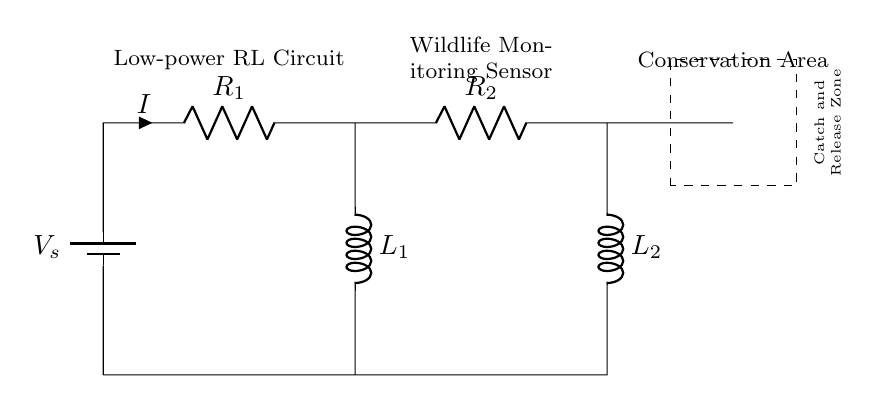What is the function of the battery in this circuit? The battery provides the voltage source needed to power the entire circuit, driving the current through the resistors and inductors.
Answer: Voltage source What are the names of the two resistors in the circuit? The resistors are labeled as R1 and R2, which indicates their positions and roles within the circuit.
Answer: R1 and R2 Which components are responsible for energy storage in the circuit? The inductors, L1 and L2, store energy in the magnetic field when current flows through them, distinguishing them from resistors, which dissipate energy.
Answer: L1 and L2 How many inductors are present in this circuit? There are two inductors, L1 and L2, connected in the circuit design, as indicated by the labels and their placement.
Answer: Two What type of sensor is being used in the circuit? The circuit includes a wildlife monitoring sensor, which is designed to function in conservation areas, helping keep track of animal movements and behaviors.
Answer: Wildlife monitoring sensor What does the dashed rectangle represent in the circuit? The dashed rectangle indicates a designated "Catch and Release Zone," suggesting an area where animals might be monitored without harm, aligning with conservation efforts.
Answer: Catch and Release Zone What is the significance of low power in this circuit? Low power consumption is crucial for wildlife monitoring sensors, as it allows for prolonged battery life and minimizes the impact on the environment, necessary for ecological conservation efforts.
Answer: Prolonged battery life 